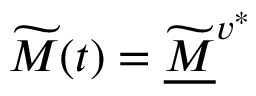Convert formula to latex. <formula><loc_0><loc_0><loc_500><loc_500>\widetilde { M } ( t ) = \widetilde { \underline { M } } ^ { v ^ { * } }</formula> 